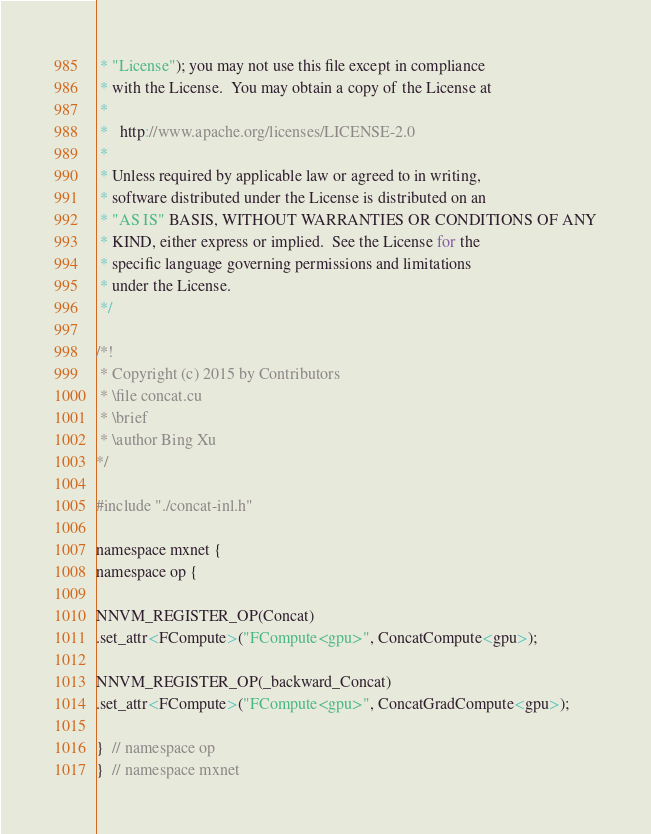<code> <loc_0><loc_0><loc_500><loc_500><_Cuda_> * "License"); you may not use this file except in compliance
 * with the License.  You may obtain a copy of the License at
 *
 *   http://www.apache.org/licenses/LICENSE-2.0
 *
 * Unless required by applicable law or agreed to in writing,
 * software distributed under the License is distributed on an
 * "AS IS" BASIS, WITHOUT WARRANTIES OR CONDITIONS OF ANY
 * KIND, either express or implied.  See the License for the
 * specific language governing permissions and limitations
 * under the License.
 */

/*!
 * Copyright (c) 2015 by Contributors
 * \file concat.cu
 * \brief
 * \author Bing Xu
*/

#include "./concat-inl.h"

namespace mxnet {
namespace op {

NNVM_REGISTER_OP(Concat)
.set_attr<FCompute>("FCompute<gpu>", ConcatCompute<gpu>);

NNVM_REGISTER_OP(_backward_Concat)
.set_attr<FCompute>("FCompute<gpu>", ConcatGradCompute<gpu>);

}  // namespace op
}  // namespace mxnet

</code> 